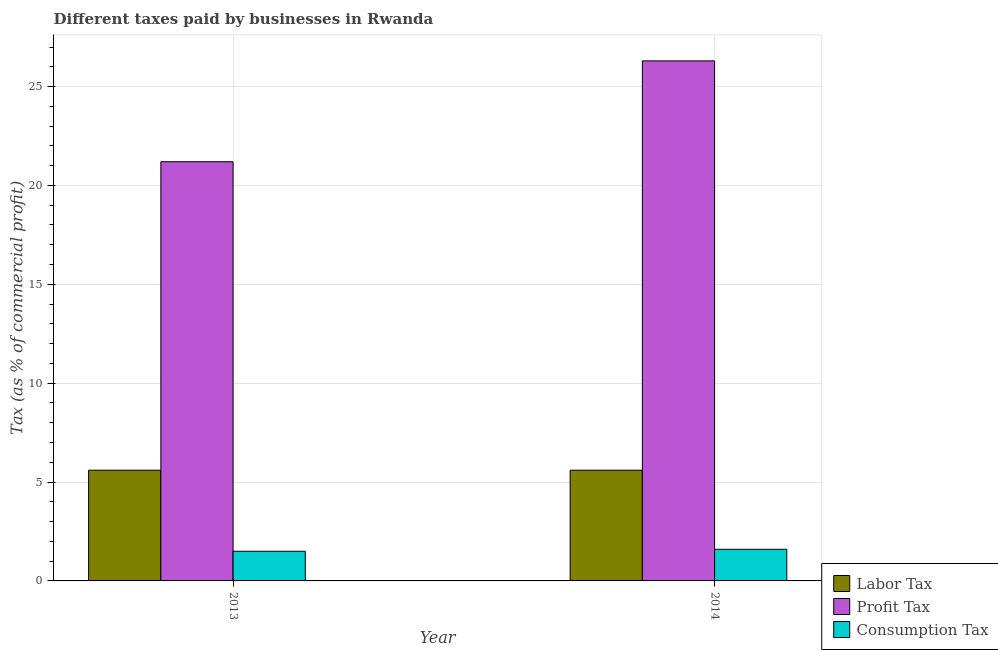How many different coloured bars are there?
Make the answer very short. 3. How many groups of bars are there?
Your answer should be very brief. 2. Are the number of bars per tick equal to the number of legend labels?
Keep it short and to the point. Yes. Are the number of bars on each tick of the X-axis equal?
Provide a short and direct response. Yes. How many bars are there on the 1st tick from the left?
Your answer should be very brief. 3. What is the percentage of consumption tax in 2014?
Your answer should be very brief. 1.6. Across all years, what is the maximum percentage of labor tax?
Your response must be concise. 5.6. Across all years, what is the minimum percentage of consumption tax?
Provide a short and direct response. 1.5. In which year was the percentage of consumption tax maximum?
Make the answer very short. 2014. What is the difference between the percentage of labor tax in 2013 and that in 2014?
Offer a terse response. 0. What is the difference between the percentage of consumption tax in 2014 and the percentage of labor tax in 2013?
Offer a terse response. 0.1. What is the ratio of the percentage of profit tax in 2013 to that in 2014?
Your answer should be compact. 0.81. Is the percentage of profit tax in 2013 less than that in 2014?
Keep it short and to the point. Yes. In how many years, is the percentage of labor tax greater than the average percentage of labor tax taken over all years?
Provide a short and direct response. 0. What does the 2nd bar from the left in 2013 represents?
Offer a very short reply. Profit Tax. What does the 2nd bar from the right in 2013 represents?
Provide a succinct answer. Profit Tax. Is it the case that in every year, the sum of the percentage of labor tax and percentage of profit tax is greater than the percentage of consumption tax?
Give a very brief answer. Yes. Are all the bars in the graph horizontal?
Offer a terse response. No. What is the difference between two consecutive major ticks on the Y-axis?
Your answer should be very brief. 5. Are the values on the major ticks of Y-axis written in scientific E-notation?
Your answer should be compact. No. Does the graph contain any zero values?
Your answer should be very brief. No. How are the legend labels stacked?
Offer a very short reply. Vertical. What is the title of the graph?
Keep it short and to the point. Different taxes paid by businesses in Rwanda. Does "Coal sources" appear as one of the legend labels in the graph?
Offer a terse response. No. What is the label or title of the X-axis?
Make the answer very short. Year. What is the label or title of the Y-axis?
Your answer should be compact. Tax (as % of commercial profit). What is the Tax (as % of commercial profit) of Profit Tax in 2013?
Make the answer very short. 21.2. What is the Tax (as % of commercial profit) of Consumption Tax in 2013?
Ensure brevity in your answer.  1.5. What is the Tax (as % of commercial profit) of Profit Tax in 2014?
Offer a terse response. 26.3. What is the Tax (as % of commercial profit) of Consumption Tax in 2014?
Make the answer very short. 1.6. Across all years, what is the maximum Tax (as % of commercial profit) of Labor Tax?
Your answer should be compact. 5.6. Across all years, what is the maximum Tax (as % of commercial profit) of Profit Tax?
Give a very brief answer. 26.3. Across all years, what is the maximum Tax (as % of commercial profit) in Consumption Tax?
Your answer should be compact. 1.6. Across all years, what is the minimum Tax (as % of commercial profit) of Profit Tax?
Give a very brief answer. 21.2. Across all years, what is the minimum Tax (as % of commercial profit) of Consumption Tax?
Give a very brief answer. 1.5. What is the total Tax (as % of commercial profit) of Profit Tax in the graph?
Your answer should be very brief. 47.5. What is the total Tax (as % of commercial profit) in Consumption Tax in the graph?
Offer a very short reply. 3.1. What is the difference between the Tax (as % of commercial profit) in Labor Tax in 2013 and that in 2014?
Your answer should be compact. 0. What is the difference between the Tax (as % of commercial profit) in Labor Tax in 2013 and the Tax (as % of commercial profit) in Profit Tax in 2014?
Your response must be concise. -20.7. What is the difference between the Tax (as % of commercial profit) of Profit Tax in 2013 and the Tax (as % of commercial profit) of Consumption Tax in 2014?
Your response must be concise. 19.6. What is the average Tax (as % of commercial profit) in Profit Tax per year?
Provide a short and direct response. 23.75. What is the average Tax (as % of commercial profit) in Consumption Tax per year?
Provide a short and direct response. 1.55. In the year 2013, what is the difference between the Tax (as % of commercial profit) in Labor Tax and Tax (as % of commercial profit) in Profit Tax?
Provide a succinct answer. -15.6. In the year 2013, what is the difference between the Tax (as % of commercial profit) of Profit Tax and Tax (as % of commercial profit) of Consumption Tax?
Your response must be concise. 19.7. In the year 2014, what is the difference between the Tax (as % of commercial profit) of Labor Tax and Tax (as % of commercial profit) of Profit Tax?
Keep it short and to the point. -20.7. In the year 2014, what is the difference between the Tax (as % of commercial profit) in Labor Tax and Tax (as % of commercial profit) in Consumption Tax?
Offer a very short reply. 4. In the year 2014, what is the difference between the Tax (as % of commercial profit) in Profit Tax and Tax (as % of commercial profit) in Consumption Tax?
Offer a very short reply. 24.7. What is the ratio of the Tax (as % of commercial profit) in Labor Tax in 2013 to that in 2014?
Keep it short and to the point. 1. What is the ratio of the Tax (as % of commercial profit) of Profit Tax in 2013 to that in 2014?
Make the answer very short. 0.81. What is the ratio of the Tax (as % of commercial profit) in Consumption Tax in 2013 to that in 2014?
Provide a succinct answer. 0.94. What is the difference between the highest and the second highest Tax (as % of commercial profit) of Consumption Tax?
Your answer should be compact. 0.1. What is the difference between the highest and the lowest Tax (as % of commercial profit) of Labor Tax?
Provide a short and direct response. 0. 